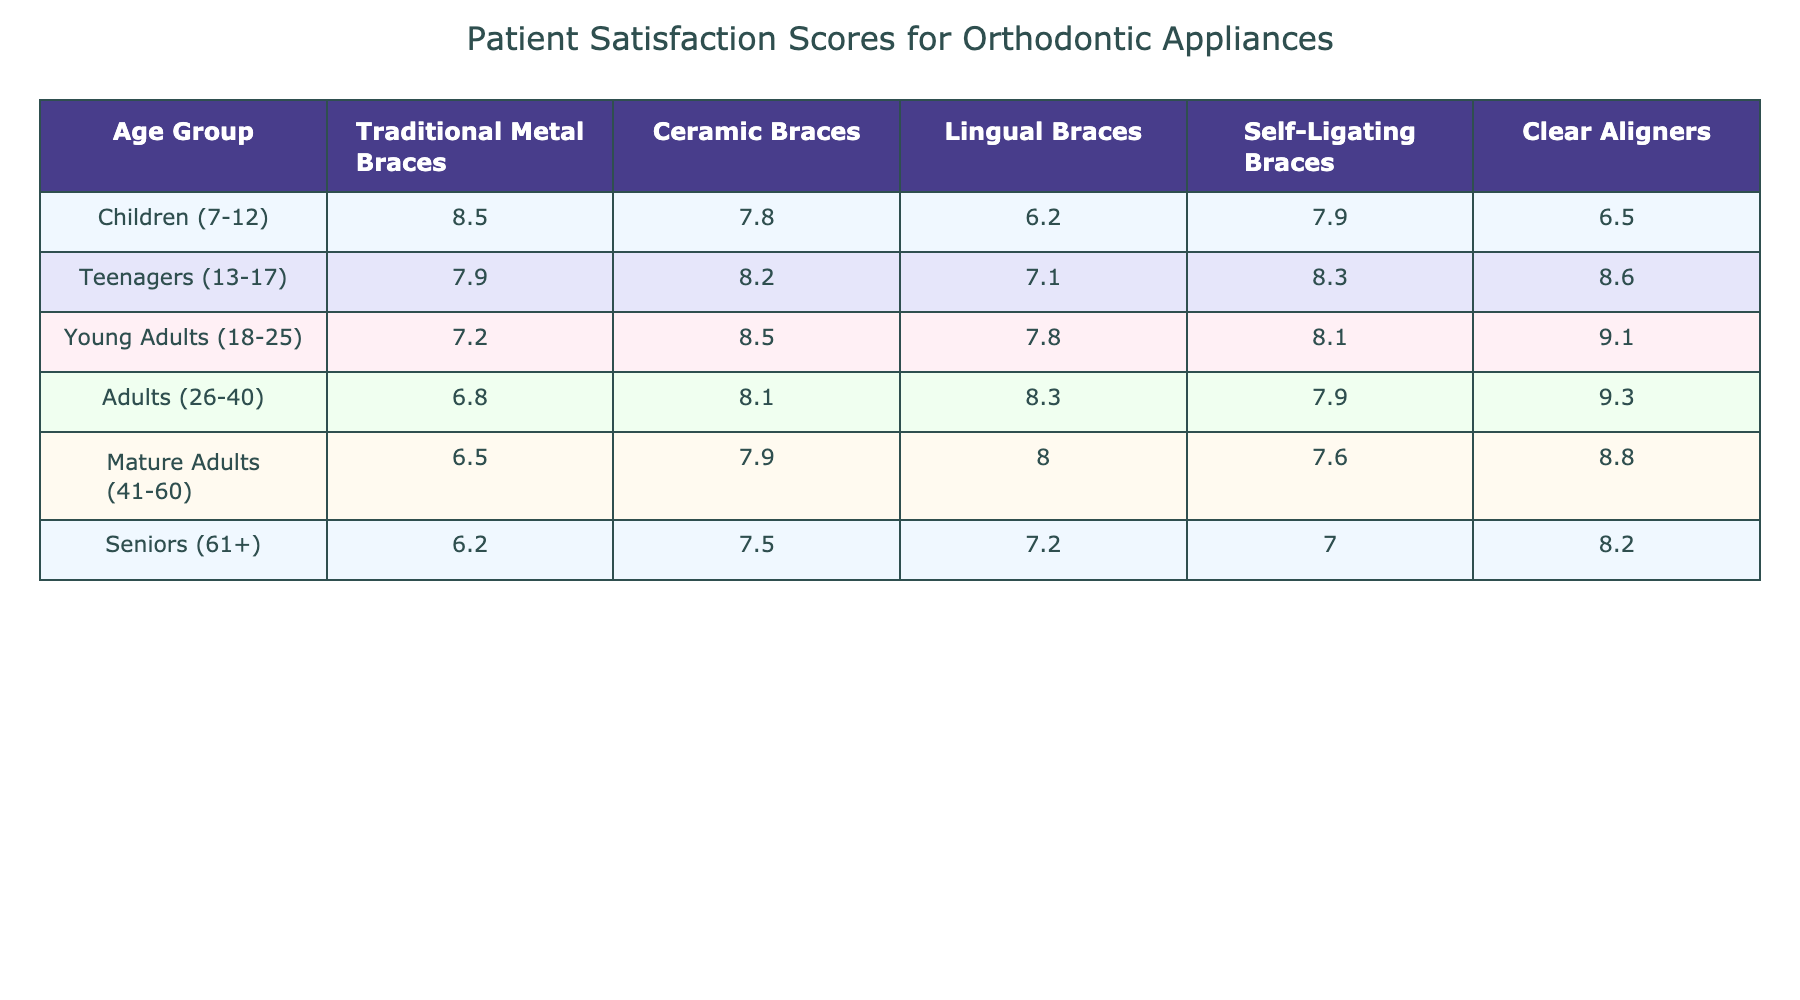What is the patient satisfaction score for Traditional Metal Braces among Teenagers? The score for Traditional Metal Braces in the Teenagers age group is directly listed in the table as 7.9.
Answer: 7.9 Which orthodontic appliance has the highest satisfaction score among Young Adults? The table indicates that Clear Aligners have the highest satisfaction score for the Young Adults age group at 9.1.
Answer: Clear Aligners What is the overall trend in satisfaction scores for Traditional Metal Braces as age increases? By observing the scores for Traditional Metal Braces: 8.5 (Children), 7.9 (Teenagers), 7.2 (Young Adults), 6.8 (Adults), 6.5 (Mature Adults), and 6.2 (Seniors), the trend shows a declining satisfaction score as age increases.
Answer: Declining What is the average satisfaction score for Ceramic Braces across all age groups? To find the average, add the scores for Ceramic Braces: 7.8 (Children) + 8.2 (Teenagers) + 8.5 (Young Adults) + 8.1 (Adults) + 7.9 (Mature Adults) + 7.5 (Seniors) = 48.0. Then divide by the number of age groups (6): 48.0 / 6 = 8.0.
Answer: 8.0 Is the satisfaction score for Self-Ligating Braces higher for Teenagers or for Young Adults? The score for Self-Ligating Braces is 8.3 for Teenagers and 8.1 for Young Adults. Since 8.3 > 8.1, the score is higher for Teenagers.
Answer: Yes What is the difference in satisfaction scores for Clear Aligners between Adults and Seniors? The score for Clear Aligners in Adults is 9.3 and in Seniors is 8.2. To find the difference, subtract: 9.3 - 8.2 = 1.1.
Answer: 1.1 Does any orthodontic appliance consistently score above 8.0 across all age groups? Checking the scores, only Clear Aligners (9.1 for Young Adults and 9.3 for Adults) are above 8.0, but for Children and Seniors, the scores are below 8.0. Thus, no orthodontic appliance consistently scores above 8.0 across all age groups.
Answer: No What are the scores for Lingual Braces in Adolescents and Mature Adults? According to the table, Lingual Braces score 7.1 in Teenagers and 8.0 in Mature Adults.
Answer: 7.1 and 8.0 Which age group has the lowest satisfaction score for any orthodontic appliance? Looking through the satisfaction scores, Seniors have the lowest score for Traditional Metal Braces at 6.2.
Answer: 6.2 What is the overall average satisfaction score for all orthodontic appliances in the Children age group? First, sum the scores for Children: 8.5 (Traditional Metal) + 7.8 (Ceramic) + 6.2 (Lingual) + 7.9 (Self-Ligating) + 6.5 (Clear Aligners) = 36.9. Then divide by the number of appliances (5): 36.9 / 5 = 7.38.
Answer: 7.38 